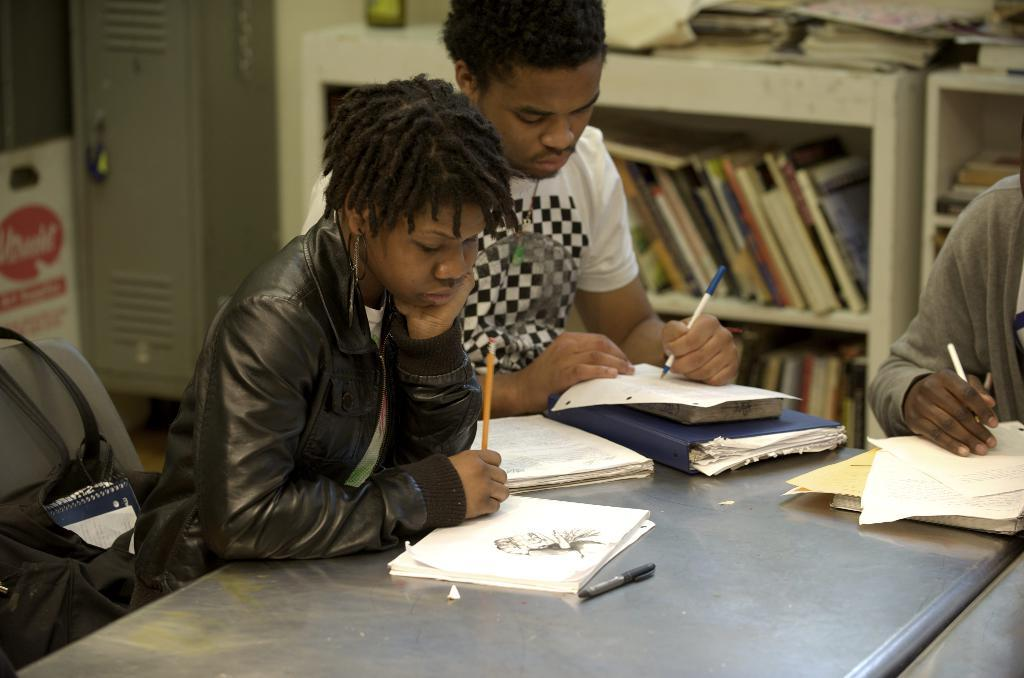How many people are in the image? There are two persons in the image. What are the persons doing while sitting on the chairs? The persons are holding pens in their hands. What might the persons be doing with the pens? The persons are writing on something, as they are holding pens. What is present in the image for the persons to sit on? There is a table in the image, and it is likely that the persons are sitting on chairs around the table. What can be seen in the background of the image? There is a book rack in the background of the image. What level of the game are the persons playing in the image? There is no game present in the image, so it is not possible to determine the level they might be playing at. 